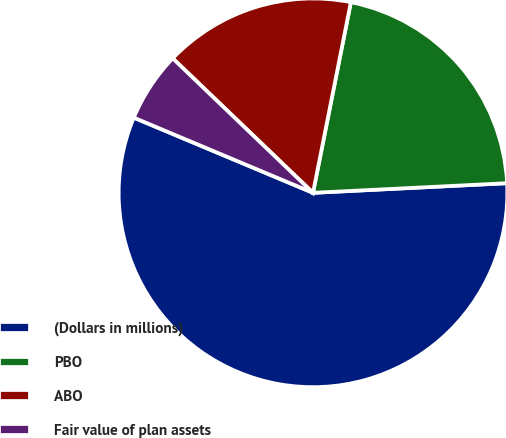Convert chart to OTSL. <chart><loc_0><loc_0><loc_500><loc_500><pie_chart><fcel>(Dollars in millions)<fcel>PBO<fcel>ABO<fcel>Fair value of plan assets<nl><fcel>57.11%<fcel>21.09%<fcel>15.96%<fcel>5.84%<nl></chart> 